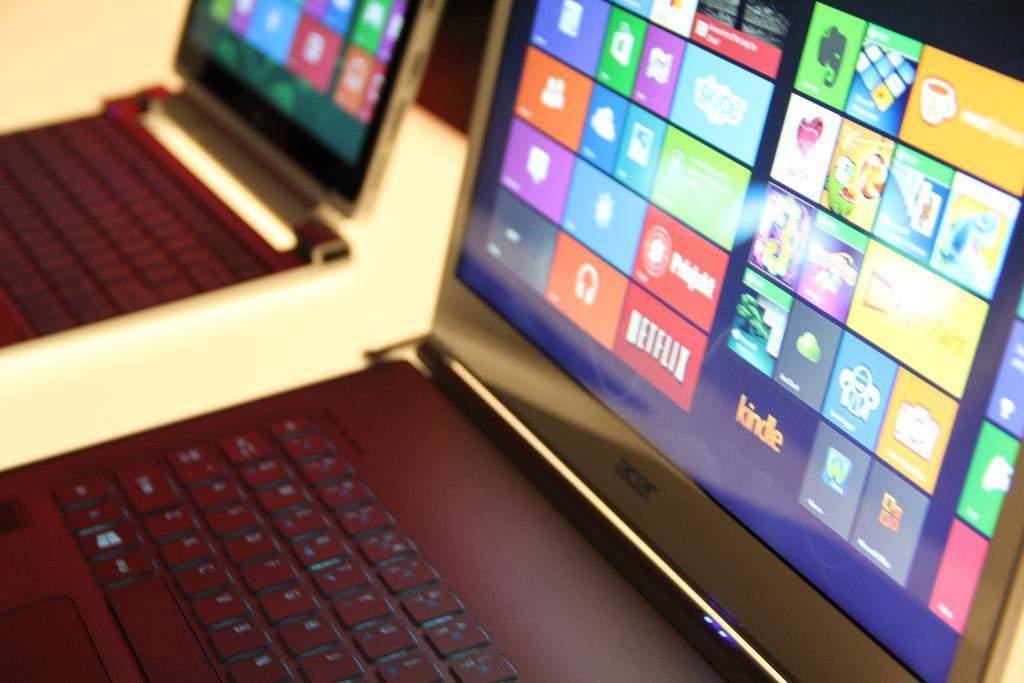Who makes these laptops?
Your answer should be compact. Acer. Which streaming app is shown?
Your answer should be very brief. Netflix. 